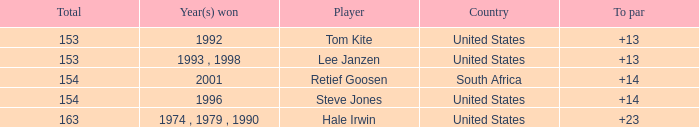In what year did the United States win To par greater than 14 1974 , 1979 , 1990. 